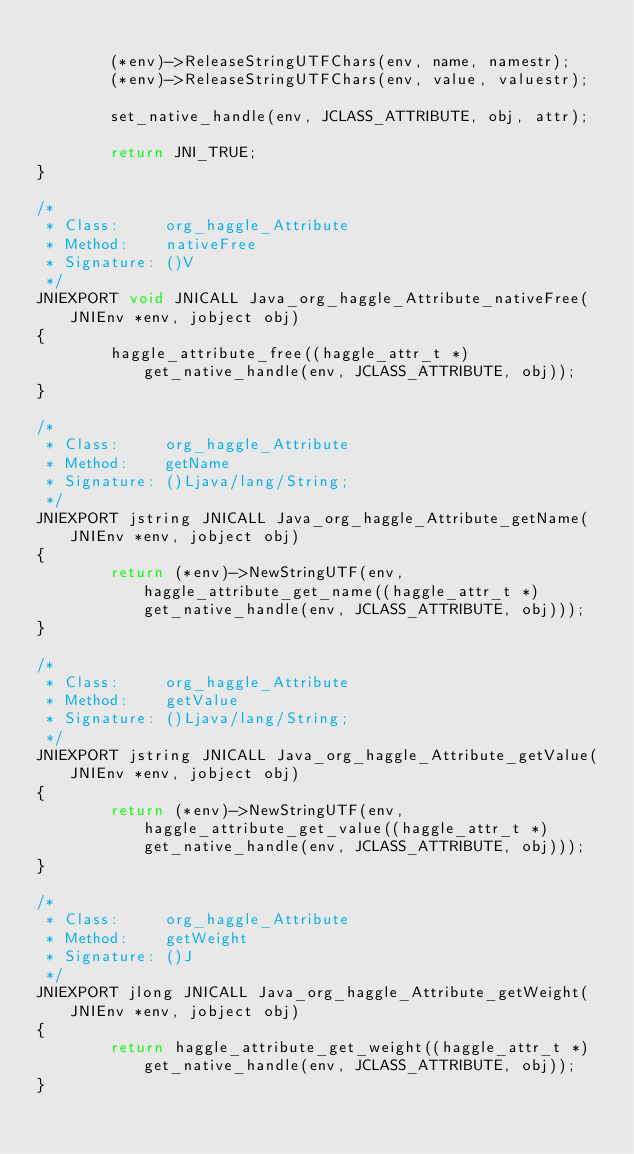<code> <loc_0><loc_0><loc_500><loc_500><_C_>        
        (*env)->ReleaseStringUTFChars(env, name, namestr);
        (*env)->ReleaseStringUTFChars(env, value, valuestr);
        
        set_native_handle(env, JCLASS_ATTRIBUTE, obj, attr);
        
        return JNI_TRUE;
}

/*
 * Class:     org_haggle_Attribute
 * Method:    nativeFree
 * Signature: ()V
 */
JNIEXPORT void JNICALL Java_org_haggle_Attribute_nativeFree(JNIEnv *env, jobject obj)
{
        haggle_attribute_free((haggle_attr_t *)get_native_handle(env, JCLASS_ATTRIBUTE, obj));
}

/*
 * Class:     org_haggle_Attribute
 * Method:    getName
 * Signature: ()Ljava/lang/String;
 */
JNIEXPORT jstring JNICALL Java_org_haggle_Attribute_getName(JNIEnv *env, jobject obj)
{
        return (*env)->NewStringUTF(env, haggle_attribute_get_name((haggle_attr_t *)get_native_handle(env, JCLASS_ATTRIBUTE, obj)));
}

/*
 * Class:     org_haggle_Attribute
 * Method:    getValue
 * Signature: ()Ljava/lang/String;
 */
JNIEXPORT jstring JNICALL Java_org_haggle_Attribute_getValue(JNIEnv *env, jobject obj)
{
        return (*env)->NewStringUTF(env, haggle_attribute_get_value((haggle_attr_t *)get_native_handle(env, JCLASS_ATTRIBUTE, obj)));
}

/*
 * Class:     org_haggle_Attribute
 * Method:    getWeight
 * Signature: ()J
 */
JNIEXPORT jlong JNICALL Java_org_haggle_Attribute_getWeight(JNIEnv *env, jobject obj)
{
        return haggle_attribute_get_weight((haggle_attr_t *)get_native_handle(env, JCLASS_ATTRIBUTE, obj));
}
</code> 